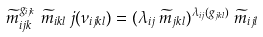Convert formula to latex. <formula><loc_0><loc_0><loc_500><loc_500>\widetilde { m } _ { i j k } ^ { g _ { i j k } \, } \, \widetilde { m } _ { i k l } \, j ( \nu _ { i j k l } ) = ( \lambda _ { i j } \, \widetilde { m } _ { j k l } ) ^ { \lambda _ { i j } ( g _ { j k l } ) \, } \, \widetilde { m } _ { i j l }</formula> 